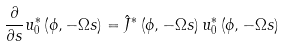Convert formula to latex. <formula><loc_0><loc_0><loc_500><loc_500>\frac { \partial } { \partial s } u _ { 0 } ^ { \ast } \left ( \phi , - \Omega s \right ) = \hat { J } ^ { \ast } \left ( \phi , - \Omega s \right ) u _ { 0 } ^ { \ast } \left ( \phi , - \Omega s \right )</formula> 